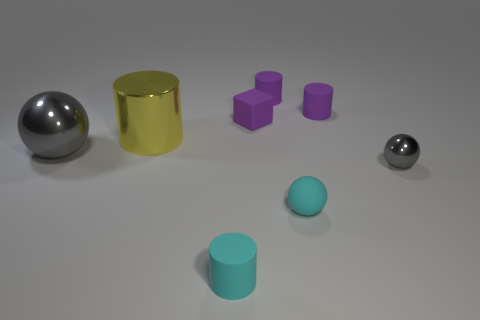Subtract all tiny cylinders. How many cylinders are left? 1 Add 2 small cyan cylinders. How many objects exist? 10 Subtract all gray spheres. How many spheres are left? 1 Subtract 1 blocks. How many blocks are left? 0 Subtract 0 cyan blocks. How many objects are left? 8 Subtract all blocks. How many objects are left? 7 Subtract all cyan cylinders. Subtract all gray balls. How many cylinders are left? 3 Subtract all gray blocks. How many gray balls are left? 2 Subtract all small cylinders. Subtract all tiny purple things. How many objects are left? 2 Add 6 large gray objects. How many large gray objects are left? 7 